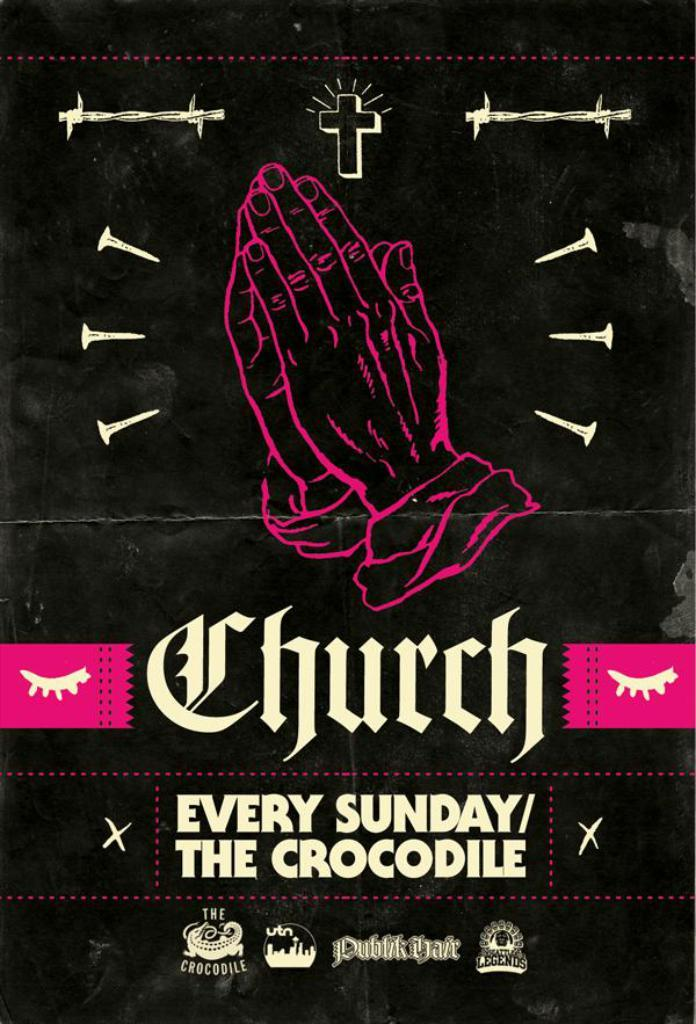<image>
Relay a brief, clear account of the picture shown. a poster saying church every Sunday the crocodile 